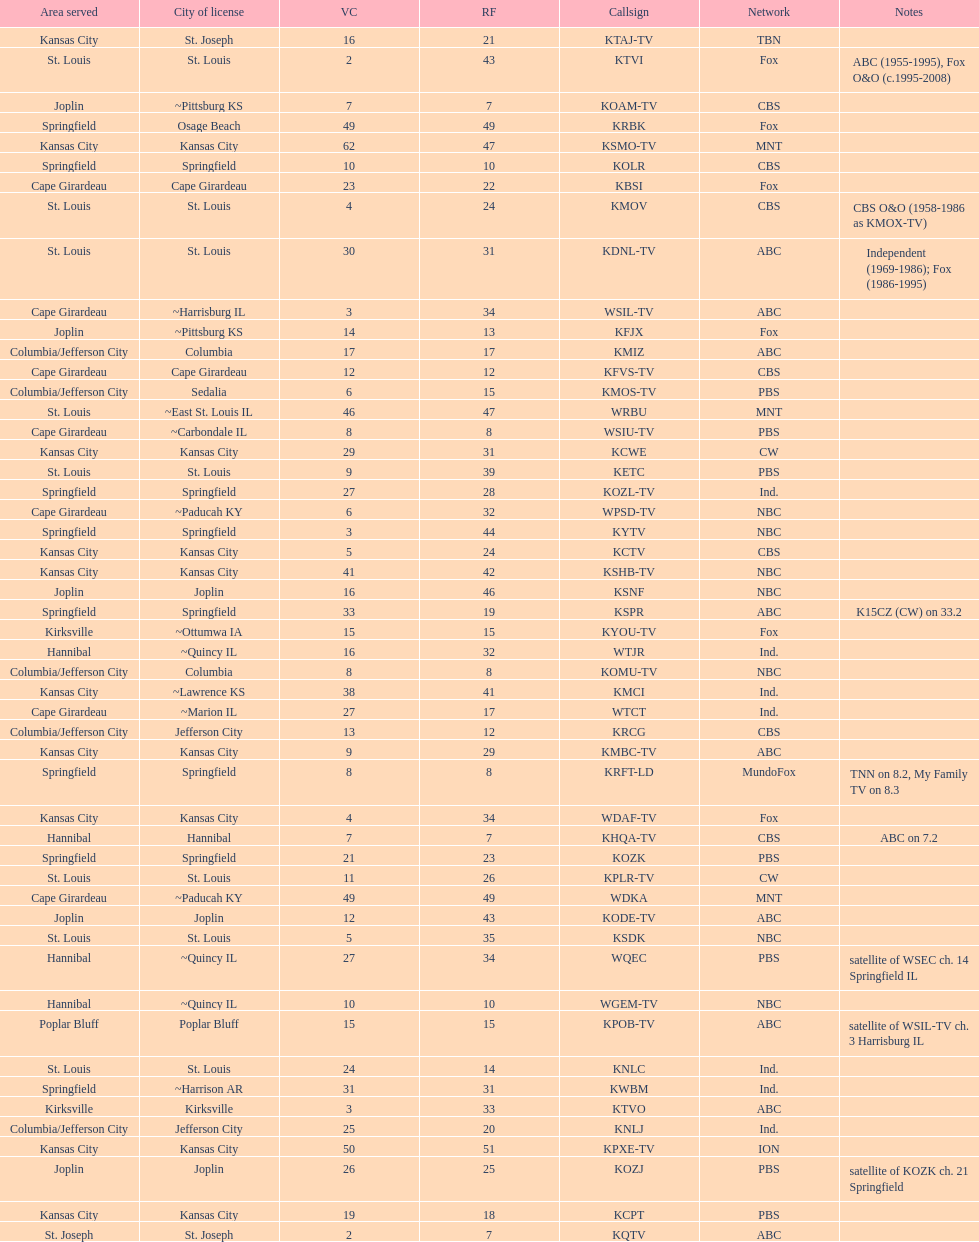Could you parse the entire table? {'header': ['Area served', 'City of license', 'VC', 'RF', 'Callsign', 'Network', 'Notes'], 'rows': [['Kansas City', 'St. Joseph', '16', '21', 'KTAJ-TV', 'TBN', ''], ['St. Louis', 'St. Louis', '2', '43', 'KTVI', 'Fox', 'ABC (1955-1995), Fox O&O (c.1995-2008)'], ['Joplin', '~Pittsburg KS', '7', '7', 'KOAM-TV', 'CBS', ''], ['Springfield', 'Osage Beach', '49', '49', 'KRBK', 'Fox', ''], ['Kansas City', 'Kansas City', '62', '47', 'KSMO-TV', 'MNT', ''], ['Springfield', 'Springfield', '10', '10', 'KOLR', 'CBS', ''], ['Cape Girardeau', 'Cape Girardeau', '23', '22', 'KBSI', 'Fox', ''], ['St. Louis', 'St. Louis', '4', '24', 'KMOV', 'CBS', 'CBS O&O (1958-1986 as KMOX-TV)'], ['St. Louis', 'St. Louis', '30', '31', 'KDNL-TV', 'ABC', 'Independent (1969-1986); Fox (1986-1995)'], ['Cape Girardeau', '~Harrisburg IL', '3', '34', 'WSIL-TV', 'ABC', ''], ['Joplin', '~Pittsburg KS', '14', '13', 'KFJX', 'Fox', ''], ['Columbia/Jefferson City', 'Columbia', '17', '17', 'KMIZ', 'ABC', ''], ['Cape Girardeau', 'Cape Girardeau', '12', '12', 'KFVS-TV', 'CBS', ''], ['Columbia/Jefferson City', 'Sedalia', '6', '15', 'KMOS-TV', 'PBS', ''], ['St. Louis', '~East St. Louis IL', '46', '47', 'WRBU', 'MNT', ''], ['Cape Girardeau', '~Carbondale IL', '8', '8', 'WSIU-TV', 'PBS', ''], ['Kansas City', 'Kansas City', '29', '31', 'KCWE', 'CW', ''], ['St. Louis', 'St. Louis', '9', '39', 'KETC', 'PBS', ''], ['Springfield', 'Springfield', '27', '28', 'KOZL-TV', 'Ind.', ''], ['Cape Girardeau', '~Paducah KY', '6', '32', 'WPSD-TV', 'NBC', ''], ['Springfield', 'Springfield', '3', '44', 'KYTV', 'NBC', ''], ['Kansas City', 'Kansas City', '5', '24', 'KCTV', 'CBS', ''], ['Kansas City', 'Kansas City', '41', '42', 'KSHB-TV', 'NBC', ''], ['Joplin', 'Joplin', '16', '46', 'KSNF', 'NBC', ''], ['Springfield', 'Springfield', '33', '19', 'KSPR', 'ABC', 'K15CZ (CW) on 33.2'], ['Kirksville', '~Ottumwa IA', '15', '15', 'KYOU-TV', 'Fox', ''], ['Hannibal', '~Quincy IL', '16', '32', 'WTJR', 'Ind.', ''], ['Columbia/Jefferson City', 'Columbia', '8', '8', 'KOMU-TV', 'NBC', ''], ['Kansas City', '~Lawrence KS', '38', '41', 'KMCI', 'Ind.', ''], ['Cape Girardeau', '~Marion IL', '27', '17', 'WTCT', 'Ind.', ''], ['Columbia/Jefferson City', 'Jefferson City', '13', '12', 'KRCG', 'CBS', ''], ['Kansas City', 'Kansas City', '9', '29', 'KMBC-TV', 'ABC', ''], ['Springfield', 'Springfield', '8', '8', 'KRFT-LD', 'MundoFox', 'TNN on 8.2, My Family TV on 8.3'], ['Kansas City', 'Kansas City', '4', '34', 'WDAF-TV', 'Fox', ''], ['Hannibal', 'Hannibal', '7', '7', 'KHQA-TV', 'CBS', 'ABC on 7.2'], ['Springfield', 'Springfield', '21', '23', 'KOZK', 'PBS', ''], ['St. Louis', 'St. Louis', '11', '26', 'KPLR-TV', 'CW', ''], ['Cape Girardeau', '~Paducah KY', '49', '49', 'WDKA', 'MNT', ''], ['Joplin', 'Joplin', '12', '43', 'KODE-TV', 'ABC', ''], ['St. Louis', 'St. Louis', '5', '35', 'KSDK', 'NBC', ''], ['Hannibal', '~Quincy IL', '27', '34', 'WQEC', 'PBS', 'satellite of WSEC ch. 14 Springfield IL'], ['Hannibal', '~Quincy IL', '10', '10', 'WGEM-TV', 'NBC', ''], ['Poplar Bluff', 'Poplar Bluff', '15', '15', 'KPOB-TV', 'ABC', 'satellite of WSIL-TV ch. 3 Harrisburg IL'], ['St. Louis', 'St. Louis', '24', '14', 'KNLC', 'Ind.', ''], ['Springfield', '~Harrison AR', '31', '31', 'KWBM', 'Ind.', ''], ['Kirksville', 'Kirksville', '3', '33', 'KTVO', 'ABC', ''], ['Columbia/Jefferson City', 'Jefferson City', '25', '20', 'KNLJ', 'Ind.', ''], ['Kansas City', 'Kansas City', '50', '51', 'KPXE-TV', 'ION', ''], ['Joplin', 'Joplin', '26', '25', 'KOZJ', 'PBS', 'satellite of KOZK ch. 21 Springfield'], ['Kansas City', 'Kansas City', '19', '18', 'KCPT', 'PBS', ''], ['St. Joseph', 'St. Joseph', '2', '7', 'KQTV', 'ABC', '']]} How many areas have at least 5 stations? 6. 